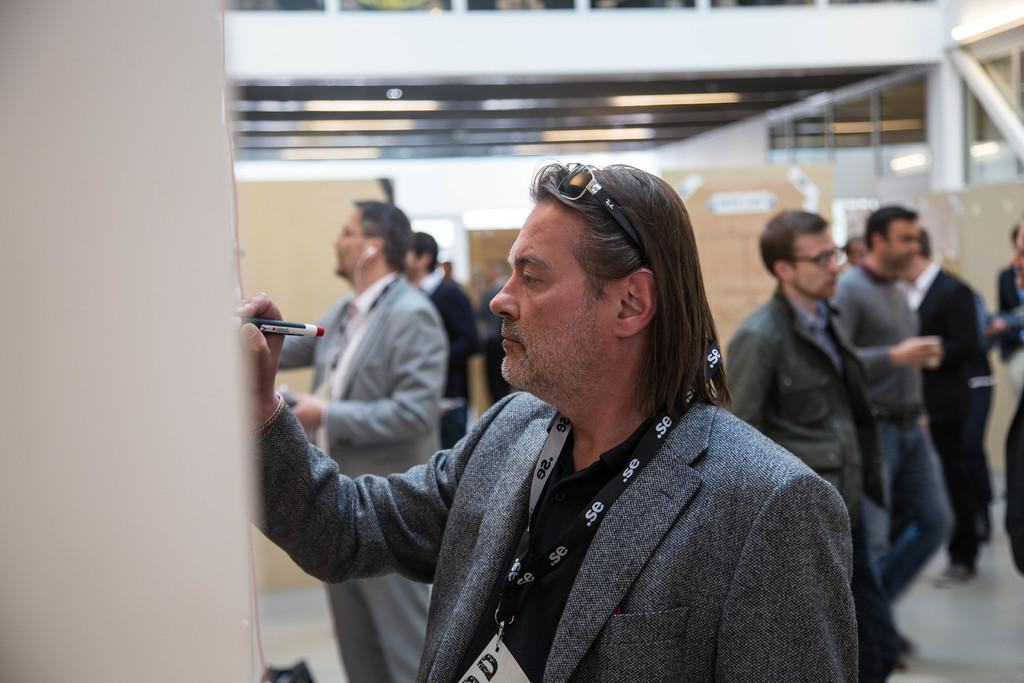How many men are in the image? There are men in the image. What is the first man doing in the image? The first man is writing something with a marker. What is the first man wearing in the image? The first man is wearing a blazer and goggles. How is the background of the people depicted in the image? The background of the people is blurred. What channel is the first man playing on the television in the image? There is no television present in the image, so it is not possible to determine what channel the first man might be playing. 